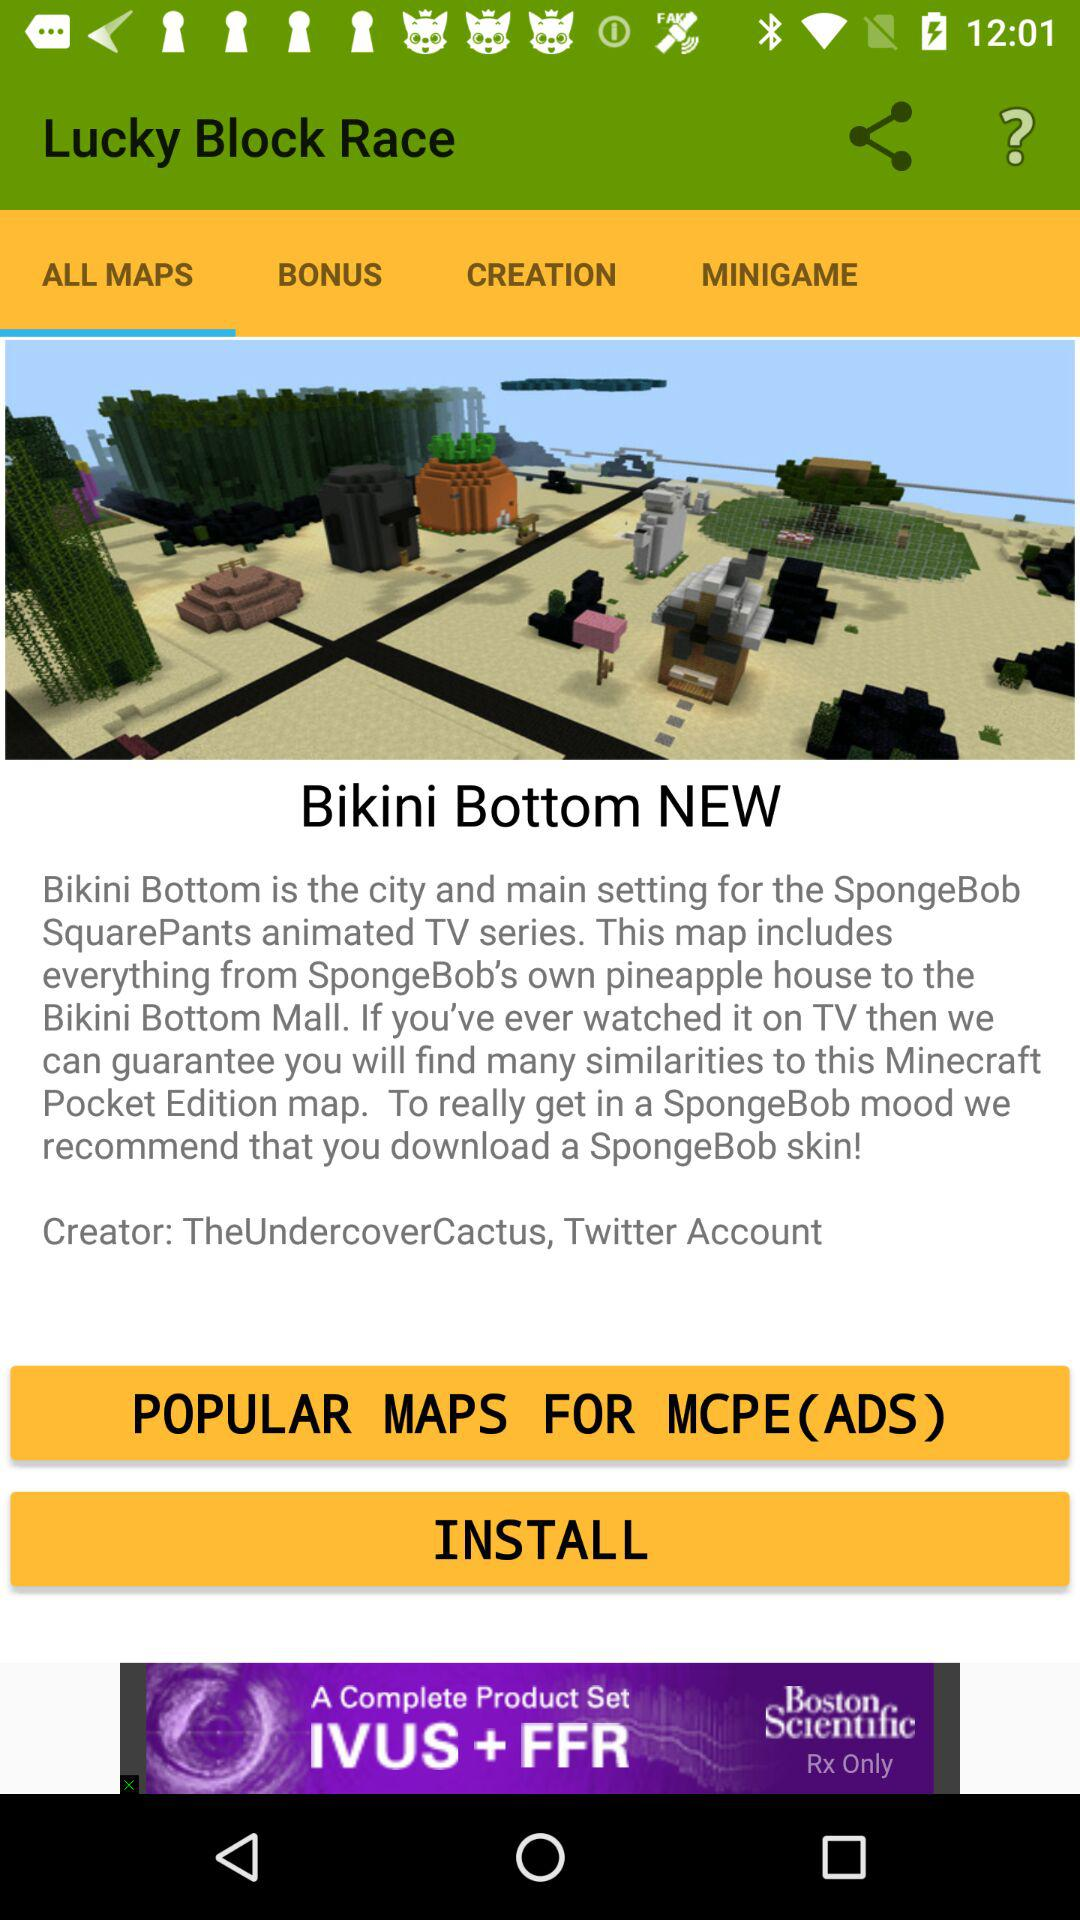What is the name of the creator? The name of the creator is "TheUndercoverCactus, Twitter Account". 